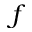Convert formula to latex. <formula><loc_0><loc_0><loc_500><loc_500>f</formula> 